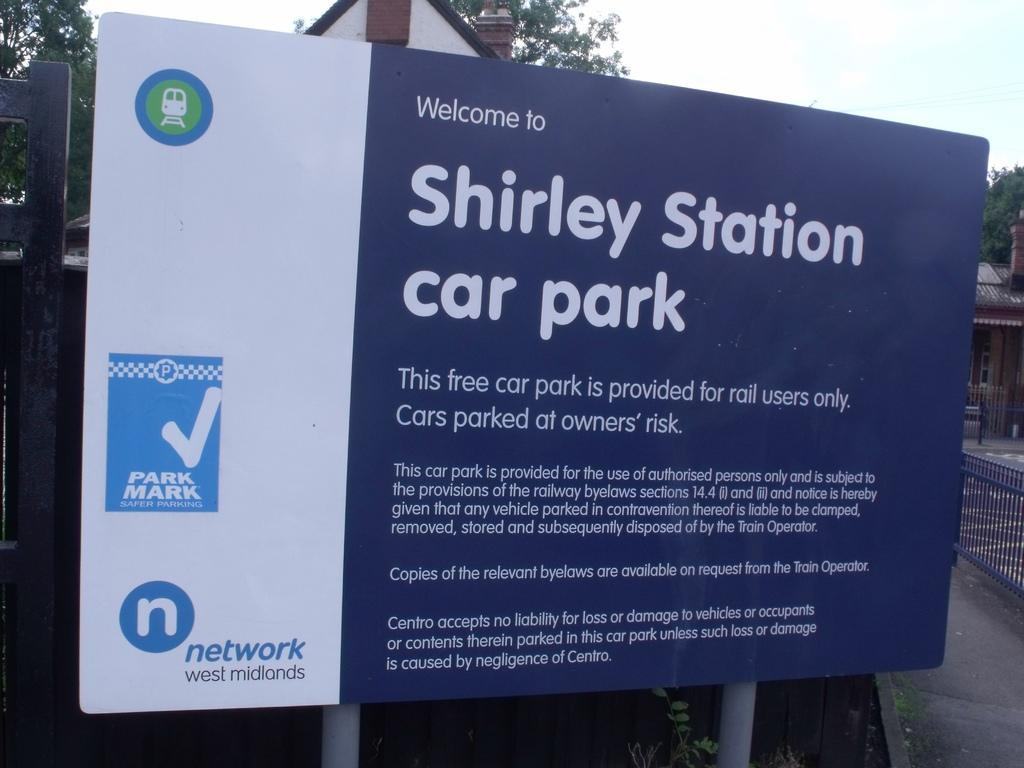<image>
Offer a succinct explanation of the picture presented. A sign for Shirley Station car park details who can use it. 